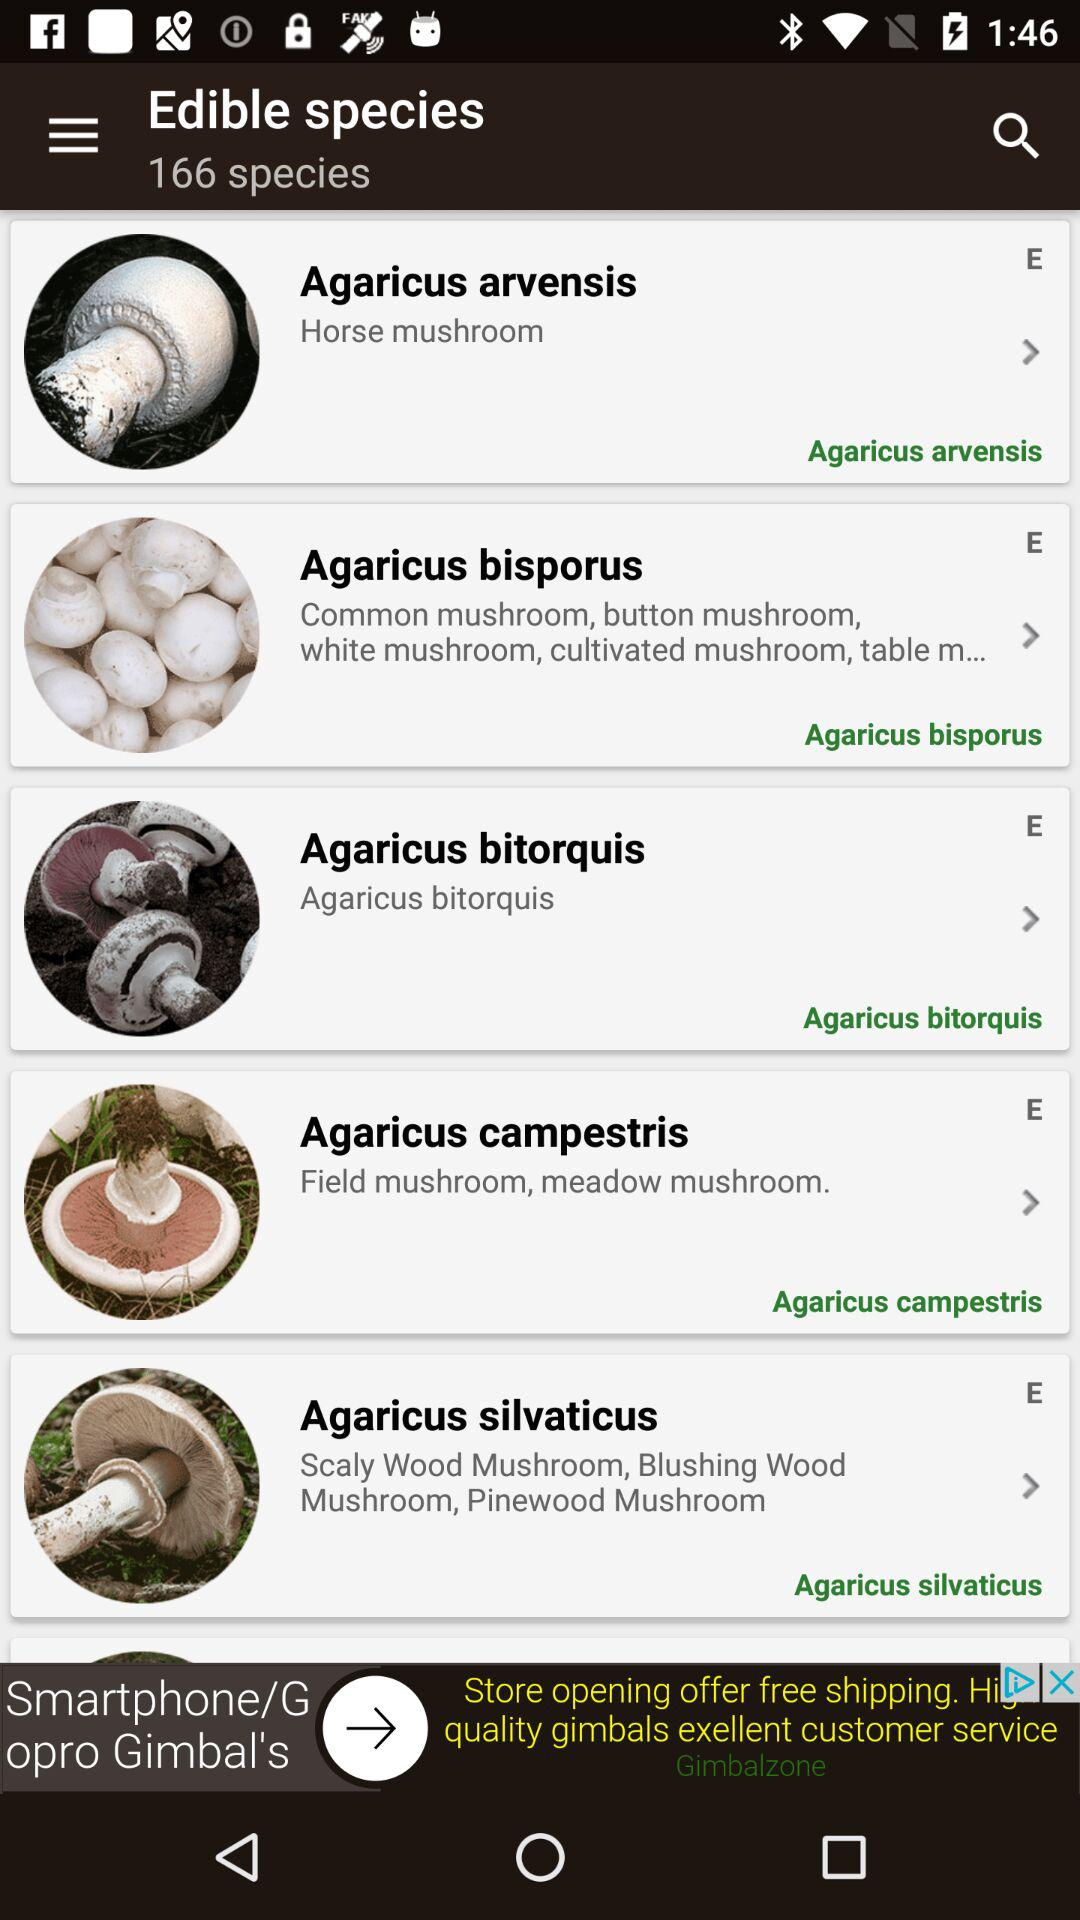Which are the edible species of mushrooms? The edible species are "Agaricus arvensis", "Agaricus bisporus", "Agaricus bitorquis", "Agaricus campestris" and "Agaricus silvaticus". 